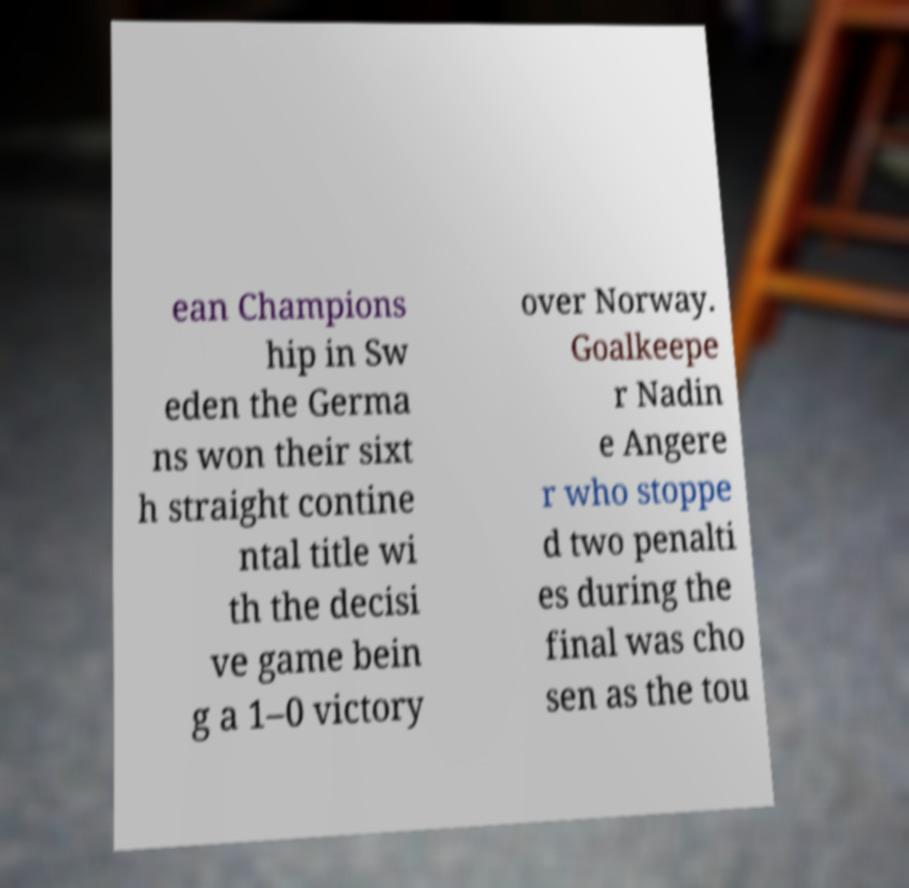There's text embedded in this image that I need extracted. Can you transcribe it verbatim? ean Champions hip in Sw eden the Germa ns won their sixt h straight contine ntal title wi th the decisi ve game bein g a 1–0 victory over Norway. Goalkeepe r Nadin e Angere r who stoppe d two penalti es during the final was cho sen as the tou 